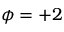Convert formula to latex. <formula><loc_0><loc_0><loc_500><loc_500>\phi = + 2</formula> 